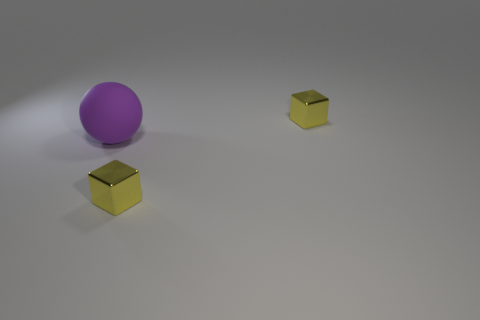Could the objects in the image serve a functional purpose together, or are they unrelated? The purple ball and golden cubes could potentially serve a functional purpose together, such as components in a game or pieces of an art installation. However, without additional context, it's just as likely that they are unrelated objects placed together for the sake of this image. The objects' simplicity leaves their use and relation to one another open to interpretation. 